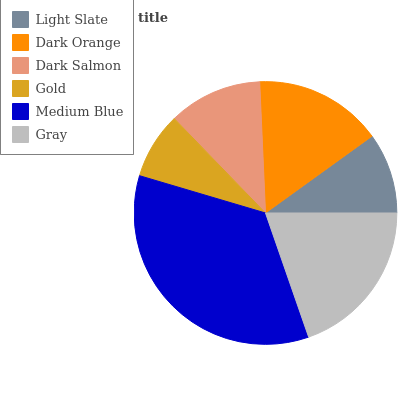Is Gold the minimum?
Answer yes or no. Yes. Is Medium Blue the maximum?
Answer yes or no. Yes. Is Dark Orange the minimum?
Answer yes or no. No. Is Dark Orange the maximum?
Answer yes or no. No. Is Dark Orange greater than Light Slate?
Answer yes or no. Yes. Is Light Slate less than Dark Orange?
Answer yes or no. Yes. Is Light Slate greater than Dark Orange?
Answer yes or no. No. Is Dark Orange less than Light Slate?
Answer yes or no. No. Is Dark Orange the high median?
Answer yes or no. Yes. Is Dark Salmon the low median?
Answer yes or no. Yes. Is Gray the high median?
Answer yes or no. No. Is Medium Blue the low median?
Answer yes or no. No. 